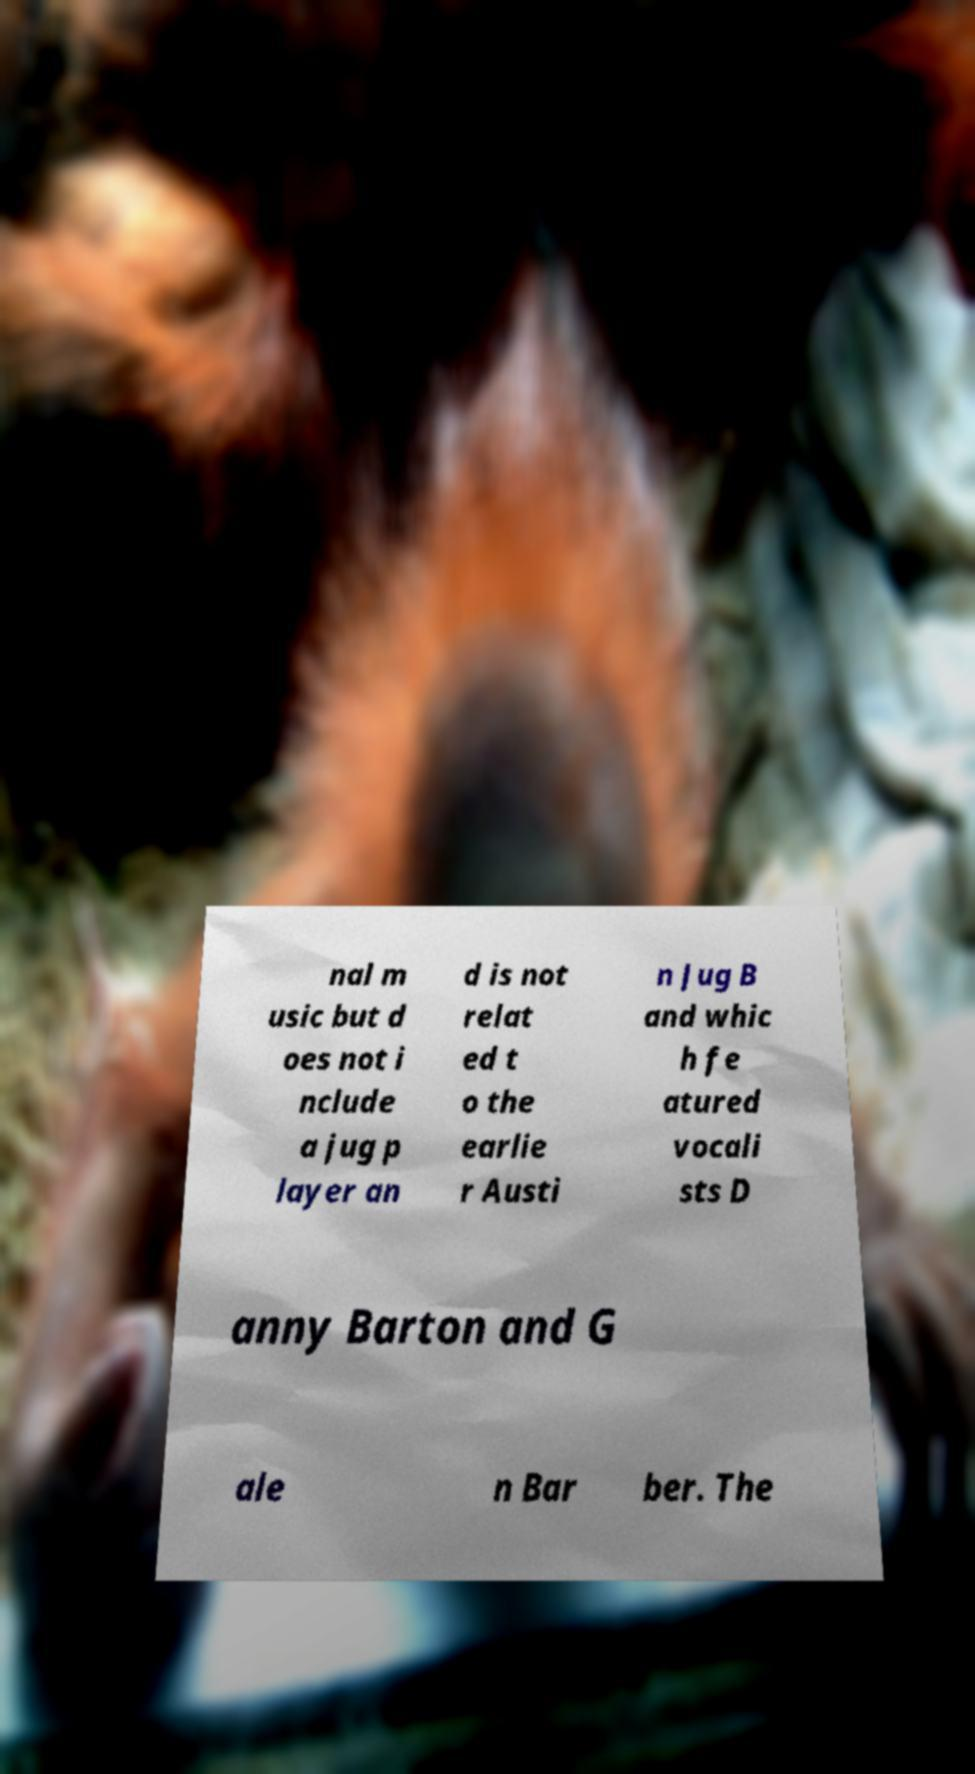Please read and relay the text visible in this image. What does it say? nal m usic but d oes not i nclude a jug p layer an d is not relat ed t o the earlie r Austi n Jug B and whic h fe atured vocali sts D anny Barton and G ale n Bar ber. The 